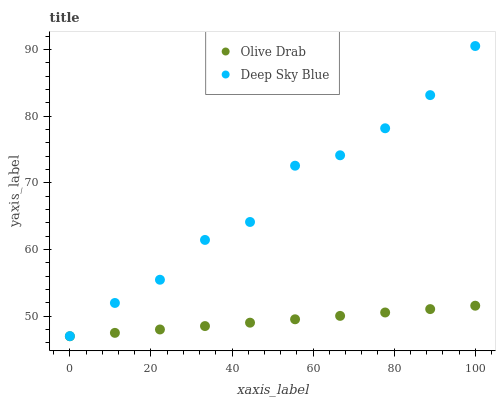Does Olive Drab have the minimum area under the curve?
Answer yes or no. Yes. Does Deep Sky Blue have the maximum area under the curve?
Answer yes or no. Yes. Does Olive Drab have the maximum area under the curve?
Answer yes or no. No. Is Olive Drab the smoothest?
Answer yes or no. Yes. Is Deep Sky Blue the roughest?
Answer yes or no. Yes. Is Olive Drab the roughest?
Answer yes or no. No. Does Olive Drab have the lowest value?
Answer yes or no. Yes. Does Deep Sky Blue have the highest value?
Answer yes or no. Yes. Does Olive Drab have the highest value?
Answer yes or no. No. Is Olive Drab less than Deep Sky Blue?
Answer yes or no. Yes. Is Deep Sky Blue greater than Olive Drab?
Answer yes or no. Yes. Does Olive Drab intersect Deep Sky Blue?
Answer yes or no. No. 